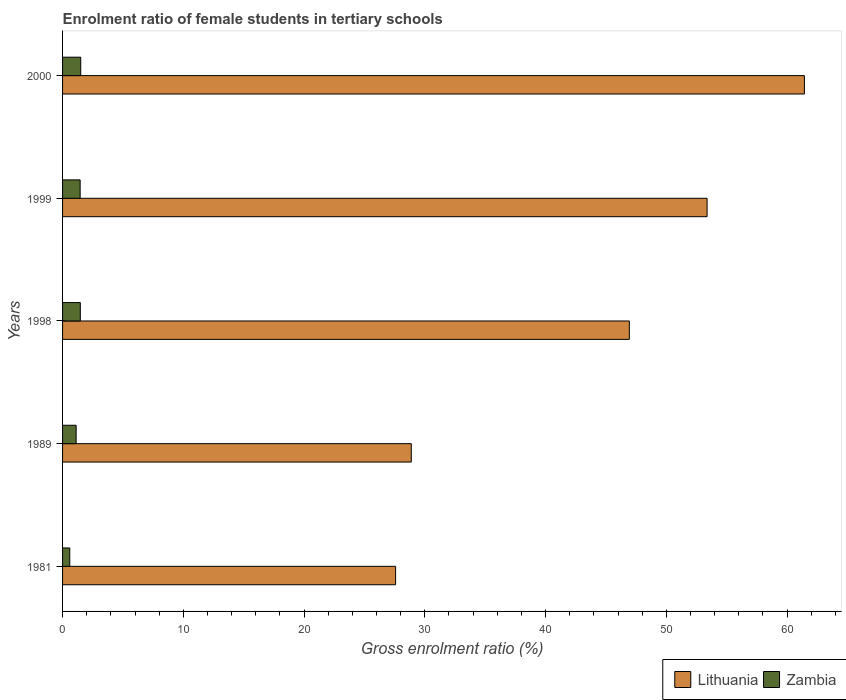How many different coloured bars are there?
Offer a terse response. 2. How many groups of bars are there?
Offer a terse response. 5. Are the number of bars per tick equal to the number of legend labels?
Your response must be concise. Yes. How many bars are there on the 3rd tick from the top?
Offer a terse response. 2. What is the label of the 3rd group of bars from the top?
Offer a terse response. 1998. What is the enrolment ratio of female students in tertiary schools in Zambia in 1989?
Offer a very short reply. 1.12. Across all years, what is the maximum enrolment ratio of female students in tertiary schools in Zambia?
Your answer should be compact. 1.51. Across all years, what is the minimum enrolment ratio of female students in tertiary schools in Lithuania?
Your answer should be compact. 27.58. In which year was the enrolment ratio of female students in tertiary schools in Zambia maximum?
Provide a short and direct response. 2000. In which year was the enrolment ratio of female students in tertiary schools in Zambia minimum?
Provide a succinct answer. 1981. What is the total enrolment ratio of female students in tertiary schools in Lithuania in the graph?
Make the answer very short. 218.2. What is the difference between the enrolment ratio of female students in tertiary schools in Lithuania in 1981 and that in 2000?
Make the answer very short. -33.85. What is the difference between the enrolment ratio of female students in tertiary schools in Zambia in 1998 and the enrolment ratio of female students in tertiary schools in Lithuania in 1989?
Offer a very short reply. -27.41. What is the average enrolment ratio of female students in tertiary schools in Lithuania per year?
Your response must be concise. 43.64. In the year 1998, what is the difference between the enrolment ratio of female students in tertiary schools in Lithuania and enrolment ratio of female students in tertiary schools in Zambia?
Keep it short and to the point. 45.46. What is the ratio of the enrolment ratio of female students in tertiary schools in Lithuania in 1998 to that in 1999?
Give a very brief answer. 0.88. Is the enrolment ratio of female students in tertiary schools in Zambia in 1989 less than that in 1999?
Offer a very short reply. Yes. What is the difference between the highest and the second highest enrolment ratio of female students in tertiary schools in Zambia?
Keep it short and to the point. 0.04. What is the difference between the highest and the lowest enrolment ratio of female students in tertiary schools in Zambia?
Keep it short and to the point. 0.91. Is the sum of the enrolment ratio of female students in tertiary schools in Zambia in 1981 and 2000 greater than the maximum enrolment ratio of female students in tertiary schools in Lithuania across all years?
Give a very brief answer. No. What does the 1st bar from the top in 1999 represents?
Offer a terse response. Zambia. What does the 2nd bar from the bottom in 1998 represents?
Offer a terse response. Zambia. How many years are there in the graph?
Offer a very short reply. 5. What is the difference between two consecutive major ticks on the X-axis?
Offer a very short reply. 10. Does the graph contain any zero values?
Make the answer very short. No. Does the graph contain grids?
Provide a short and direct response. No. What is the title of the graph?
Your answer should be compact. Enrolment ratio of female students in tertiary schools. Does "Sudan" appear as one of the legend labels in the graph?
Offer a terse response. No. What is the label or title of the X-axis?
Give a very brief answer. Gross enrolment ratio (%). What is the label or title of the Y-axis?
Your answer should be very brief. Years. What is the Gross enrolment ratio (%) of Lithuania in 1981?
Offer a terse response. 27.58. What is the Gross enrolment ratio (%) of Zambia in 1981?
Make the answer very short. 0.6. What is the Gross enrolment ratio (%) of Lithuania in 1989?
Keep it short and to the point. 28.88. What is the Gross enrolment ratio (%) of Zambia in 1989?
Provide a succinct answer. 1.12. What is the Gross enrolment ratio (%) of Lithuania in 1998?
Your answer should be very brief. 46.93. What is the Gross enrolment ratio (%) in Zambia in 1998?
Offer a very short reply. 1.47. What is the Gross enrolment ratio (%) of Lithuania in 1999?
Make the answer very short. 53.37. What is the Gross enrolment ratio (%) of Zambia in 1999?
Provide a short and direct response. 1.46. What is the Gross enrolment ratio (%) in Lithuania in 2000?
Keep it short and to the point. 61.43. What is the Gross enrolment ratio (%) of Zambia in 2000?
Make the answer very short. 1.51. Across all years, what is the maximum Gross enrolment ratio (%) in Lithuania?
Provide a short and direct response. 61.43. Across all years, what is the maximum Gross enrolment ratio (%) of Zambia?
Provide a short and direct response. 1.51. Across all years, what is the minimum Gross enrolment ratio (%) in Lithuania?
Provide a short and direct response. 27.58. Across all years, what is the minimum Gross enrolment ratio (%) in Zambia?
Keep it short and to the point. 0.6. What is the total Gross enrolment ratio (%) in Lithuania in the graph?
Your response must be concise. 218.2. What is the total Gross enrolment ratio (%) of Zambia in the graph?
Provide a succinct answer. 6.15. What is the difference between the Gross enrolment ratio (%) of Lithuania in 1981 and that in 1989?
Provide a succinct answer. -1.3. What is the difference between the Gross enrolment ratio (%) in Zambia in 1981 and that in 1989?
Provide a short and direct response. -0.53. What is the difference between the Gross enrolment ratio (%) of Lithuania in 1981 and that in 1998?
Your answer should be very brief. -19.35. What is the difference between the Gross enrolment ratio (%) of Zambia in 1981 and that in 1998?
Your response must be concise. -0.87. What is the difference between the Gross enrolment ratio (%) in Lithuania in 1981 and that in 1999?
Provide a succinct answer. -25.79. What is the difference between the Gross enrolment ratio (%) in Zambia in 1981 and that in 1999?
Give a very brief answer. -0.86. What is the difference between the Gross enrolment ratio (%) of Lithuania in 1981 and that in 2000?
Offer a very short reply. -33.85. What is the difference between the Gross enrolment ratio (%) in Zambia in 1981 and that in 2000?
Keep it short and to the point. -0.91. What is the difference between the Gross enrolment ratio (%) of Lithuania in 1989 and that in 1998?
Ensure brevity in your answer.  -18.06. What is the difference between the Gross enrolment ratio (%) of Zambia in 1989 and that in 1998?
Give a very brief answer. -0.35. What is the difference between the Gross enrolment ratio (%) in Lithuania in 1989 and that in 1999?
Keep it short and to the point. -24.5. What is the difference between the Gross enrolment ratio (%) of Zambia in 1989 and that in 1999?
Your answer should be very brief. -0.33. What is the difference between the Gross enrolment ratio (%) of Lithuania in 1989 and that in 2000?
Offer a terse response. -32.55. What is the difference between the Gross enrolment ratio (%) in Zambia in 1989 and that in 2000?
Keep it short and to the point. -0.38. What is the difference between the Gross enrolment ratio (%) in Lithuania in 1998 and that in 1999?
Provide a short and direct response. -6.44. What is the difference between the Gross enrolment ratio (%) in Zambia in 1998 and that in 1999?
Keep it short and to the point. 0.01. What is the difference between the Gross enrolment ratio (%) in Lithuania in 1998 and that in 2000?
Your response must be concise. -14.5. What is the difference between the Gross enrolment ratio (%) of Zambia in 1998 and that in 2000?
Keep it short and to the point. -0.04. What is the difference between the Gross enrolment ratio (%) in Lithuania in 1999 and that in 2000?
Give a very brief answer. -8.06. What is the difference between the Gross enrolment ratio (%) in Zambia in 1999 and that in 2000?
Your response must be concise. -0.05. What is the difference between the Gross enrolment ratio (%) in Lithuania in 1981 and the Gross enrolment ratio (%) in Zambia in 1989?
Ensure brevity in your answer.  26.46. What is the difference between the Gross enrolment ratio (%) of Lithuania in 1981 and the Gross enrolment ratio (%) of Zambia in 1998?
Ensure brevity in your answer.  26.11. What is the difference between the Gross enrolment ratio (%) of Lithuania in 1981 and the Gross enrolment ratio (%) of Zambia in 1999?
Offer a terse response. 26.12. What is the difference between the Gross enrolment ratio (%) in Lithuania in 1981 and the Gross enrolment ratio (%) in Zambia in 2000?
Provide a short and direct response. 26.07. What is the difference between the Gross enrolment ratio (%) of Lithuania in 1989 and the Gross enrolment ratio (%) of Zambia in 1998?
Make the answer very short. 27.41. What is the difference between the Gross enrolment ratio (%) of Lithuania in 1989 and the Gross enrolment ratio (%) of Zambia in 1999?
Provide a short and direct response. 27.42. What is the difference between the Gross enrolment ratio (%) in Lithuania in 1989 and the Gross enrolment ratio (%) in Zambia in 2000?
Your answer should be very brief. 27.37. What is the difference between the Gross enrolment ratio (%) of Lithuania in 1998 and the Gross enrolment ratio (%) of Zambia in 1999?
Ensure brevity in your answer.  45.48. What is the difference between the Gross enrolment ratio (%) in Lithuania in 1998 and the Gross enrolment ratio (%) in Zambia in 2000?
Give a very brief answer. 45.43. What is the difference between the Gross enrolment ratio (%) in Lithuania in 1999 and the Gross enrolment ratio (%) in Zambia in 2000?
Your answer should be very brief. 51.87. What is the average Gross enrolment ratio (%) in Lithuania per year?
Provide a succinct answer. 43.64. What is the average Gross enrolment ratio (%) in Zambia per year?
Your answer should be very brief. 1.23. In the year 1981, what is the difference between the Gross enrolment ratio (%) of Lithuania and Gross enrolment ratio (%) of Zambia?
Offer a terse response. 26.98. In the year 1989, what is the difference between the Gross enrolment ratio (%) of Lithuania and Gross enrolment ratio (%) of Zambia?
Ensure brevity in your answer.  27.75. In the year 1998, what is the difference between the Gross enrolment ratio (%) of Lithuania and Gross enrolment ratio (%) of Zambia?
Your answer should be very brief. 45.46. In the year 1999, what is the difference between the Gross enrolment ratio (%) in Lithuania and Gross enrolment ratio (%) in Zambia?
Provide a short and direct response. 51.92. In the year 2000, what is the difference between the Gross enrolment ratio (%) in Lithuania and Gross enrolment ratio (%) in Zambia?
Ensure brevity in your answer.  59.93. What is the ratio of the Gross enrolment ratio (%) in Lithuania in 1981 to that in 1989?
Provide a succinct answer. 0.96. What is the ratio of the Gross enrolment ratio (%) of Zambia in 1981 to that in 1989?
Your answer should be very brief. 0.53. What is the ratio of the Gross enrolment ratio (%) in Lithuania in 1981 to that in 1998?
Your answer should be very brief. 0.59. What is the ratio of the Gross enrolment ratio (%) in Zambia in 1981 to that in 1998?
Your response must be concise. 0.41. What is the ratio of the Gross enrolment ratio (%) of Lithuania in 1981 to that in 1999?
Offer a very short reply. 0.52. What is the ratio of the Gross enrolment ratio (%) of Zambia in 1981 to that in 1999?
Keep it short and to the point. 0.41. What is the ratio of the Gross enrolment ratio (%) of Lithuania in 1981 to that in 2000?
Make the answer very short. 0.45. What is the ratio of the Gross enrolment ratio (%) of Zambia in 1981 to that in 2000?
Keep it short and to the point. 0.4. What is the ratio of the Gross enrolment ratio (%) of Lithuania in 1989 to that in 1998?
Provide a short and direct response. 0.62. What is the ratio of the Gross enrolment ratio (%) of Zambia in 1989 to that in 1998?
Your answer should be compact. 0.76. What is the ratio of the Gross enrolment ratio (%) in Lithuania in 1989 to that in 1999?
Offer a very short reply. 0.54. What is the ratio of the Gross enrolment ratio (%) in Zambia in 1989 to that in 1999?
Your answer should be very brief. 0.77. What is the ratio of the Gross enrolment ratio (%) of Lithuania in 1989 to that in 2000?
Your answer should be very brief. 0.47. What is the ratio of the Gross enrolment ratio (%) of Zambia in 1989 to that in 2000?
Provide a succinct answer. 0.75. What is the ratio of the Gross enrolment ratio (%) in Lithuania in 1998 to that in 1999?
Provide a succinct answer. 0.88. What is the ratio of the Gross enrolment ratio (%) of Zambia in 1998 to that in 1999?
Your response must be concise. 1.01. What is the ratio of the Gross enrolment ratio (%) in Lithuania in 1998 to that in 2000?
Your answer should be very brief. 0.76. What is the ratio of the Gross enrolment ratio (%) in Zambia in 1998 to that in 2000?
Offer a very short reply. 0.98. What is the ratio of the Gross enrolment ratio (%) of Lithuania in 1999 to that in 2000?
Ensure brevity in your answer.  0.87. What is the ratio of the Gross enrolment ratio (%) of Zambia in 1999 to that in 2000?
Your answer should be very brief. 0.97. What is the difference between the highest and the second highest Gross enrolment ratio (%) of Lithuania?
Make the answer very short. 8.06. What is the difference between the highest and the second highest Gross enrolment ratio (%) in Zambia?
Keep it short and to the point. 0.04. What is the difference between the highest and the lowest Gross enrolment ratio (%) of Lithuania?
Provide a short and direct response. 33.85. What is the difference between the highest and the lowest Gross enrolment ratio (%) in Zambia?
Offer a very short reply. 0.91. 